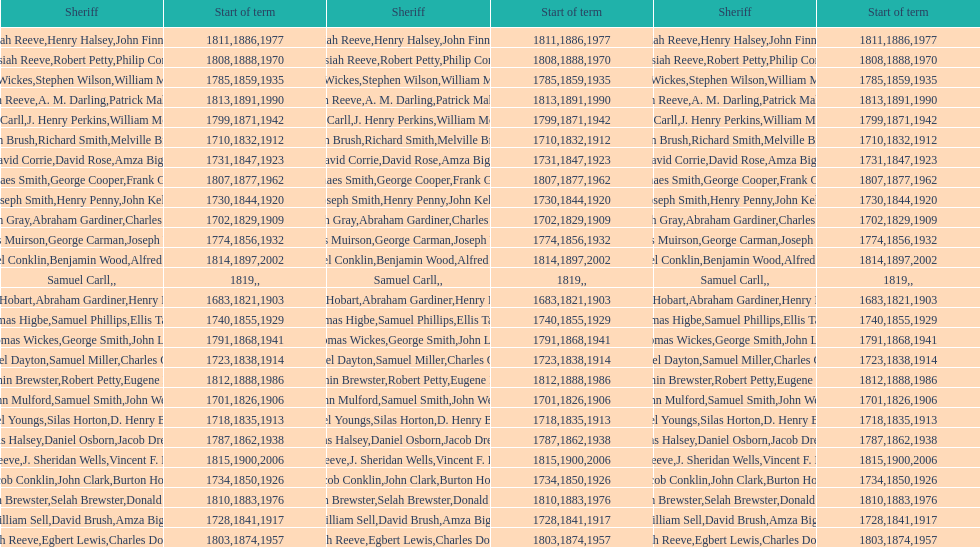Did robert petty's service precede josiah reeve's? No. 